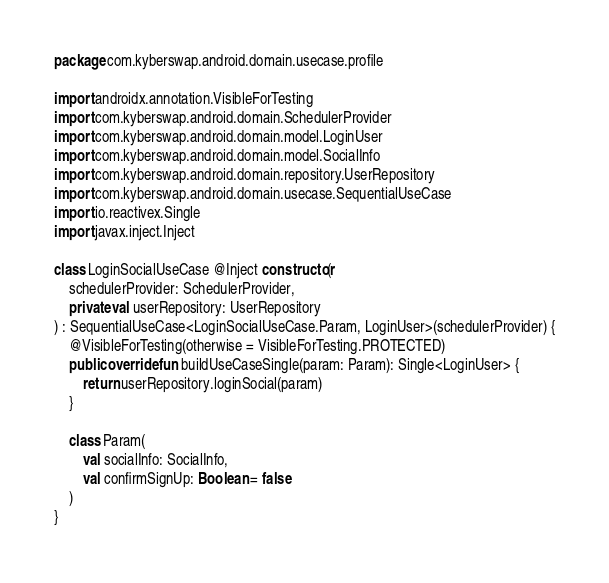<code> <loc_0><loc_0><loc_500><loc_500><_Kotlin_>package com.kyberswap.android.domain.usecase.profile

import androidx.annotation.VisibleForTesting
import com.kyberswap.android.domain.SchedulerProvider
import com.kyberswap.android.domain.model.LoginUser
import com.kyberswap.android.domain.model.SocialInfo
import com.kyberswap.android.domain.repository.UserRepository
import com.kyberswap.android.domain.usecase.SequentialUseCase
import io.reactivex.Single
import javax.inject.Inject

class LoginSocialUseCase @Inject constructor(
    schedulerProvider: SchedulerProvider,
    private val userRepository: UserRepository
) : SequentialUseCase<LoginSocialUseCase.Param, LoginUser>(schedulerProvider) {
    @VisibleForTesting(otherwise = VisibleForTesting.PROTECTED)
    public override fun buildUseCaseSingle(param: Param): Single<LoginUser> {
        return userRepository.loginSocial(param)
    }

    class Param(
        val socialInfo: SocialInfo,
        val confirmSignUp: Boolean = false
    )
}
</code> 